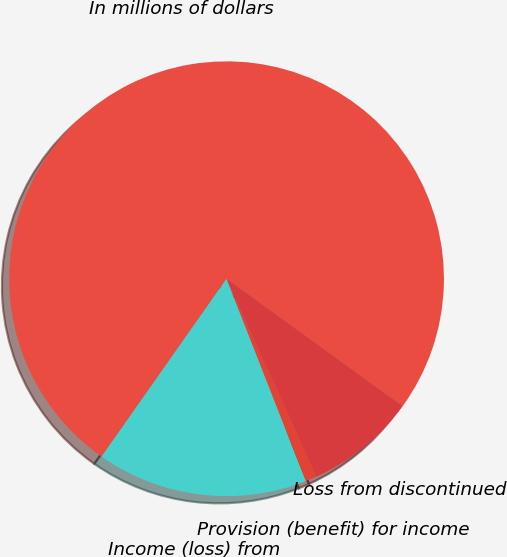Convert chart. <chart><loc_0><loc_0><loc_500><loc_500><pie_chart><fcel>In millions of dollars<fcel>Income (loss) from<fcel>Provision (benefit) for income<fcel>Loss from discontinued<nl><fcel>75.22%<fcel>15.7%<fcel>0.82%<fcel>8.26%<nl></chart> 